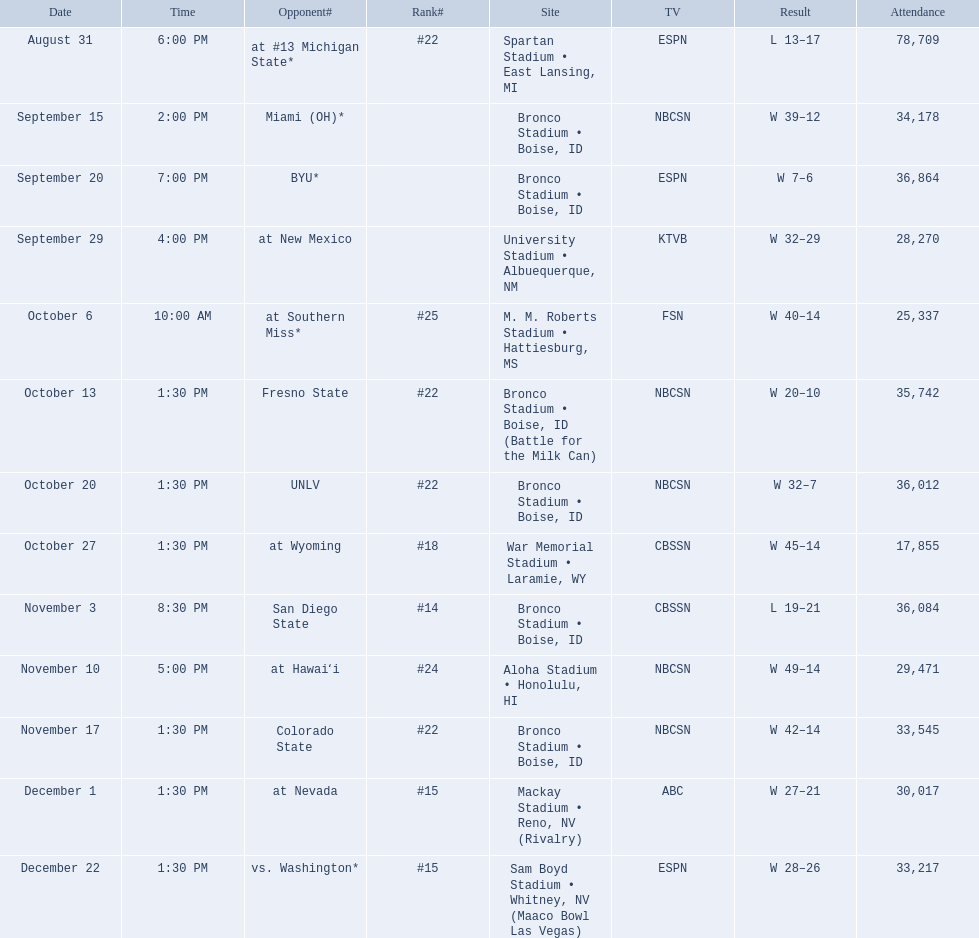What are the complete standings? #22, , , , #25, #22, #22, #18, #14, #24, #22, #15, #15. Which one held the top spot? #14. 